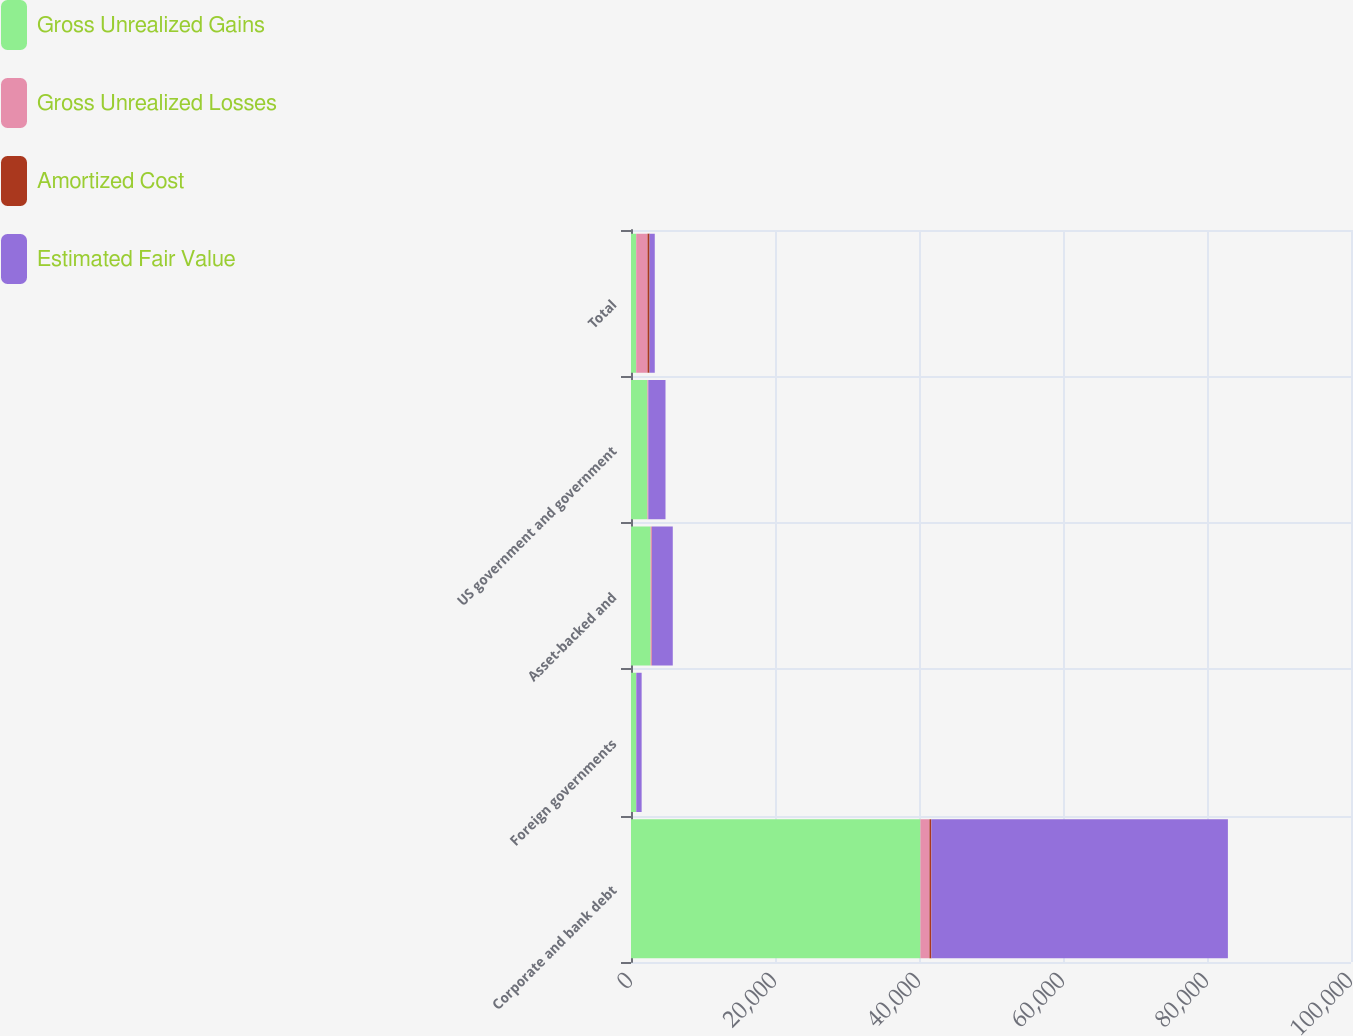<chart> <loc_0><loc_0><loc_500><loc_500><stacked_bar_chart><ecel><fcel>Corporate and bank debt<fcel>Foreign governments<fcel>Asset-backed and<fcel>US government and government<fcel>Total<nl><fcel>Gross Unrealized Gains<fcel>40194<fcel>706<fcel>2731<fcel>2281<fcel>722<nl><fcel>Gross Unrealized Losses<fcel>1257<fcel>33<fcel>170<fcel>115<fcel>1575<nl><fcel>Amortized Cost<fcel>265<fcel>1<fcel>6<fcel>10<fcel>282<nl><fcel>Estimated Fair Value<fcel>41186<fcel>738<fcel>2895<fcel>2386<fcel>722<nl></chart> 